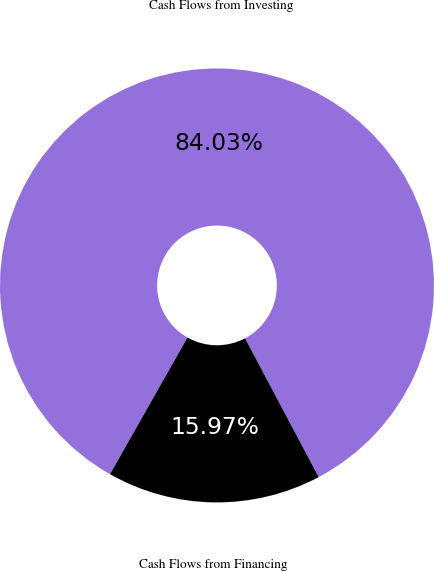<chart> <loc_0><loc_0><loc_500><loc_500><pie_chart><fcel>Cash Flows from Investing<fcel>Cash Flows from Financing<nl><fcel>84.03%<fcel>15.97%<nl></chart> 